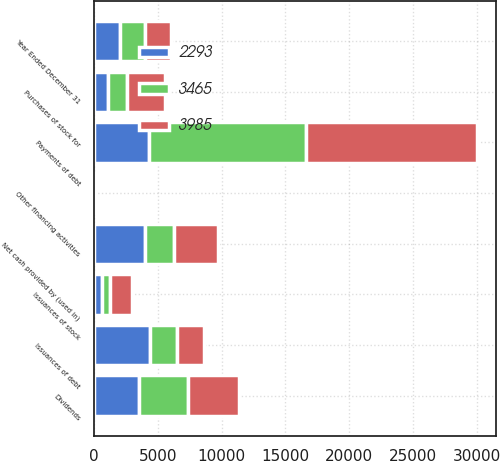Convert chart. <chart><loc_0><loc_0><loc_500><loc_500><stacked_bar_chart><ecel><fcel>Year Ended December 31<fcel>Issuances of debt<fcel>Payments of debt<fcel>Issuances of stock<fcel>Purchases of stock for<fcel>Dividends<fcel>Other financing activities<fcel>Net cash provided by (used in)<nl><fcel>3985<fcel>2010<fcel>2151.5<fcel>13403<fcel>1666<fcel>2961<fcel>4068<fcel>50<fcel>3465<nl><fcel>3465<fcel>2009<fcel>2151.5<fcel>12326<fcel>664<fcel>1518<fcel>3800<fcel>2<fcel>2293<nl><fcel>2293<fcel>2008<fcel>4337<fcel>4308<fcel>595<fcel>1079<fcel>3521<fcel>9<fcel>3985<nl></chart> 